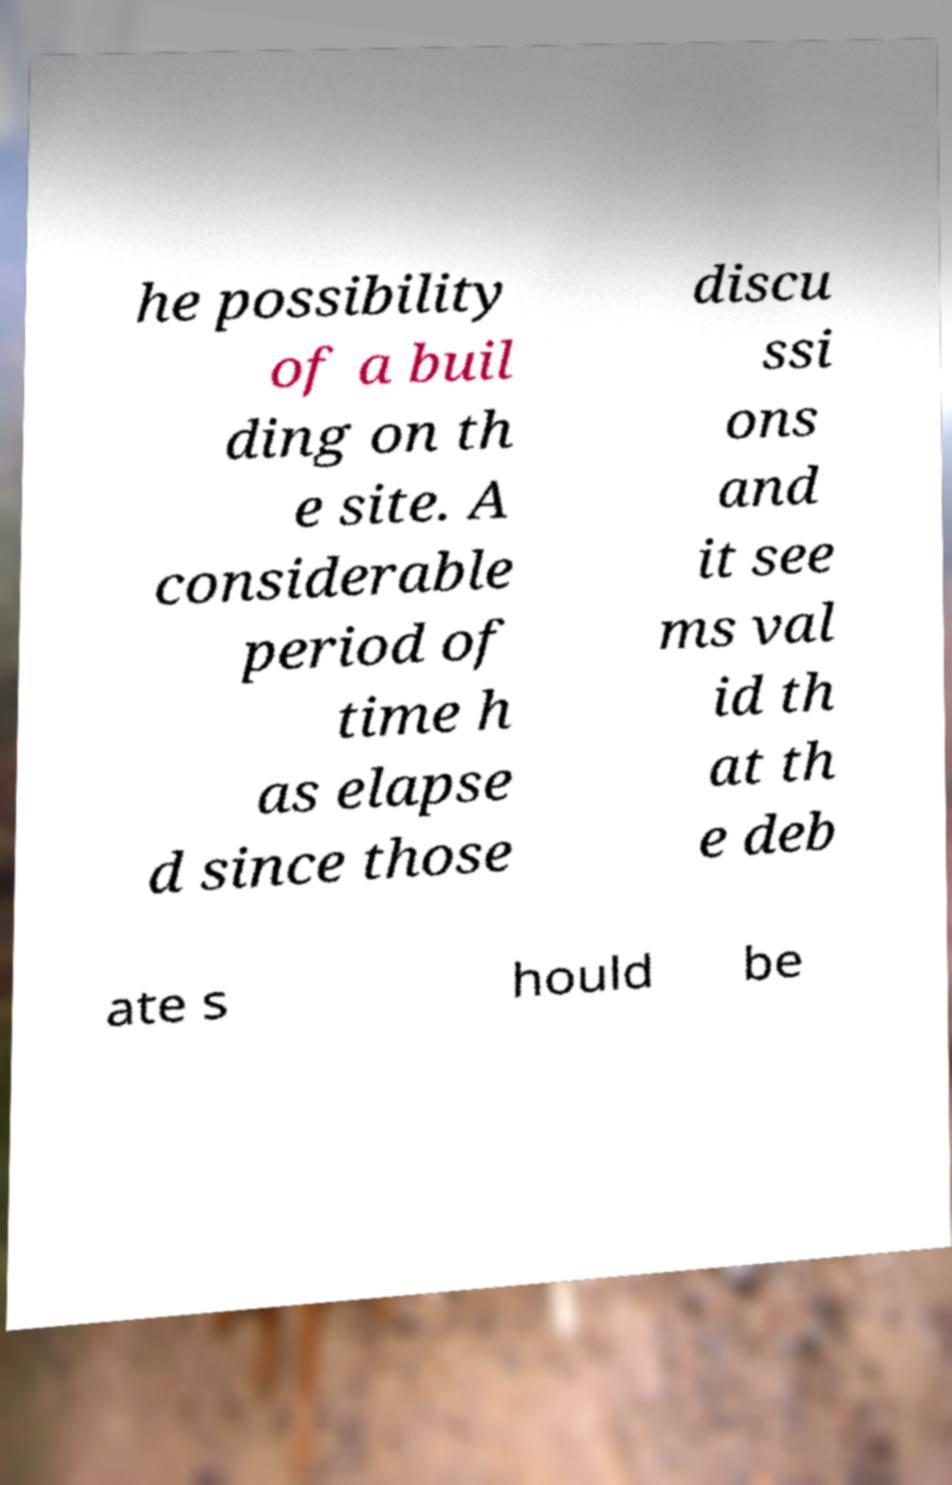There's text embedded in this image that I need extracted. Can you transcribe it verbatim? he possibility of a buil ding on th e site. A considerable period of time h as elapse d since those discu ssi ons and it see ms val id th at th e deb ate s hould be 